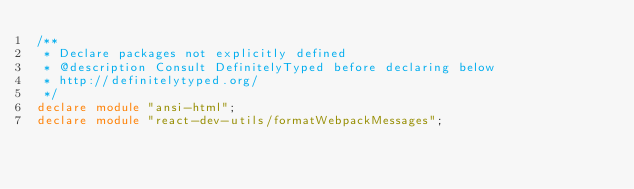Convert code to text. <code><loc_0><loc_0><loc_500><loc_500><_TypeScript_>/**
 * Declare packages not explicitly defined
 * @description Consult DefinitelyTyped before declaring below
 * http://definitelytyped.org/
 */
declare module "ansi-html";
declare module "react-dev-utils/formatWebpackMessages";
</code> 